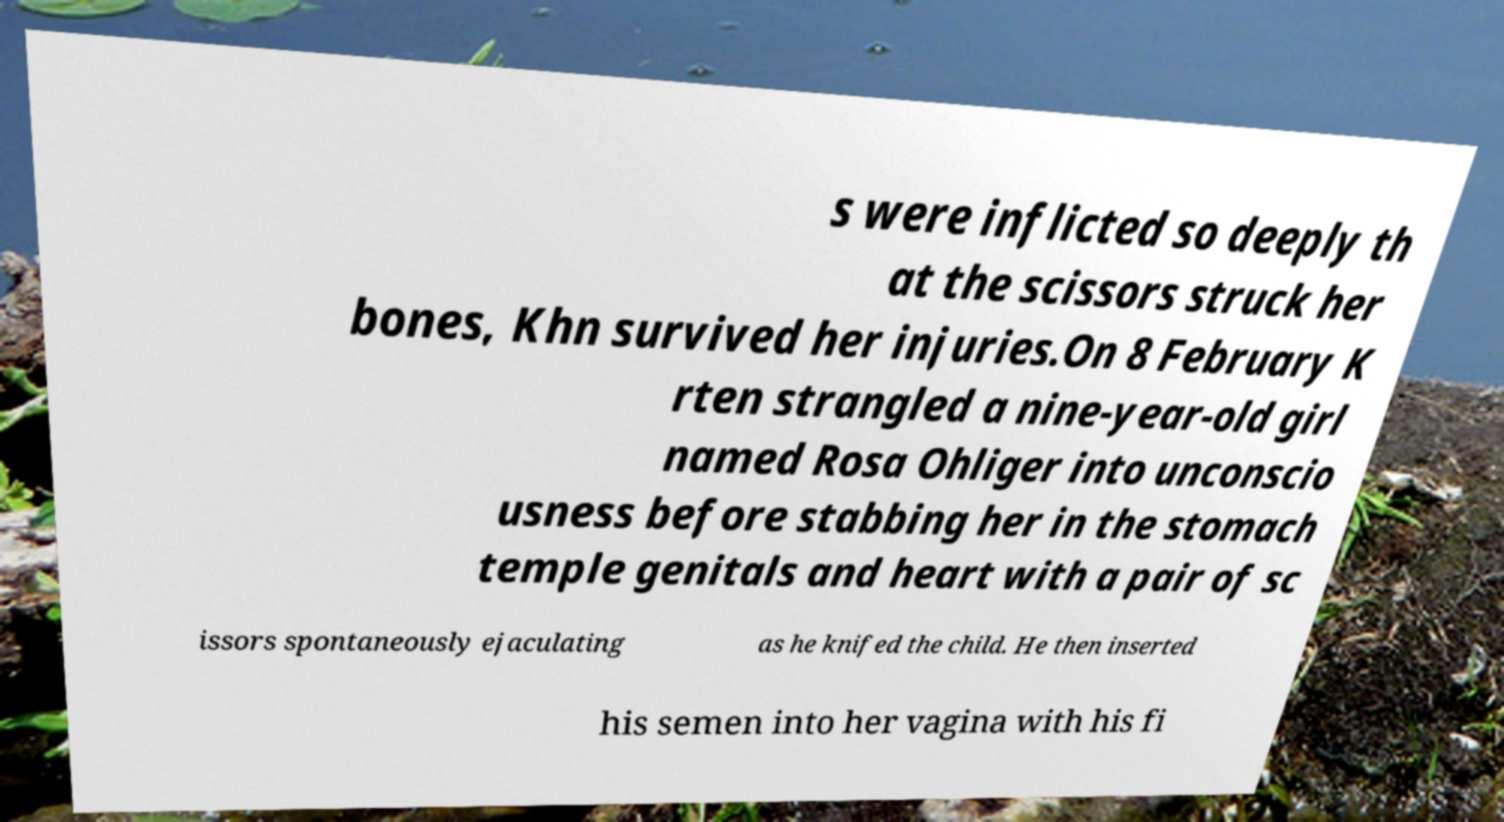Could you assist in decoding the text presented in this image and type it out clearly? s were inflicted so deeply th at the scissors struck her bones, Khn survived her injuries.On 8 February K rten strangled a nine-year-old girl named Rosa Ohliger into unconscio usness before stabbing her in the stomach temple genitals and heart with a pair of sc issors spontaneously ejaculating as he knifed the child. He then inserted his semen into her vagina with his fi 